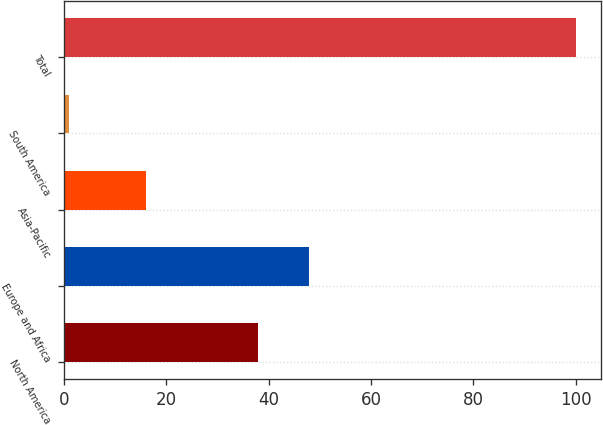Convert chart to OTSL. <chart><loc_0><loc_0><loc_500><loc_500><bar_chart><fcel>North America<fcel>Europe and Africa<fcel>Asia-Pacific<fcel>South America<fcel>Total<nl><fcel>38<fcel>47.9<fcel>16<fcel>1<fcel>100<nl></chart> 